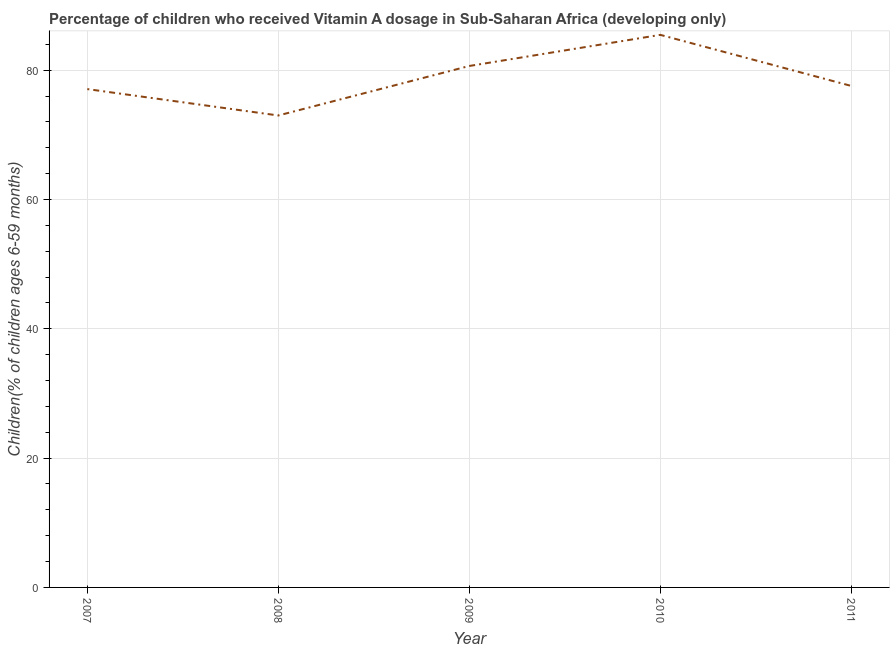What is the vitamin a supplementation coverage rate in 2009?
Make the answer very short. 80.65. Across all years, what is the maximum vitamin a supplementation coverage rate?
Ensure brevity in your answer.  85.46. Across all years, what is the minimum vitamin a supplementation coverage rate?
Make the answer very short. 72.99. In which year was the vitamin a supplementation coverage rate maximum?
Provide a succinct answer. 2010. In which year was the vitamin a supplementation coverage rate minimum?
Ensure brevity in your answer.  2008. What is the sum of the vitamin a supplementation coverage rate?
Offer a very short reply. 393.73. What is the difference between the vitamin a supplementation coverage rate in 2010 and 2011?
Offer a terse response. 7.9. What is the average vitamin a supplementation coverage rate per year?
Ensure brevity in your answer.  78.75. What is the median vitamin a supplementation coverage rate?
Your answer should be very brief. 77.56. Do a majority of the years between 2009 and 2011 (inclusive) have vitamin a supplementation coverage rate greater than 72 %?
Provide a short and direct response. Yes. What is the ratio of the vitamin a supplementation coverage rate in 2008 to that in 2009?
Your answer should be very brief. 0.91. Is the vitamin a supplementation coverage rate in 2010 less than that in 2011?
Your answer should be compact. No. What is the difference between the highest and the second highest vitamin a supplementation coverage rate?
Your response must be concise. 4.81. Is the sum of the vitamin a supplementation coverage rate in 2008 and 2010 greater than the maximum vitamin a supplementation coverage rate across all years?
Ensure brevity in your answer.  Yes. What is the difference between the highest and the lowest vitamin a supplementation coverage rate?
Your response must be concise. 12.47. How many years are there in the graph?
Your answer should be very brief. 5. Does the graph contain any zero values?
Give a very brief answer. No. What is the title of the graph?
Provide a succinct answer. Percentage of children who received Vitamin A dosage in Sub-Saharan Africa (developing only). What is the label or title of the Y-axis?
Your answer should be compact. Children(% of children ages 6-59 months). What is the Children(% of children ages 6-59 months) in 2007?
Give a very brief answer. 77.07. What is the Children(% of children ages 6-59 months) in 2008?
Offer a very short reply. 72.99. What is the Children(% of children ages 6-59 months) of 2009?
Provide a succinct answer. 80.65. What is the Children(% of children ages 6-59 months) of 2010?
Keep it short and to the point. 85.46. What is the Children(% of children ages 6-59 months) in 2011?
Your answer should be very brief. 77.56. What is the difference between the Children(% of children ages 6-59 months) in 2007 and 2008?
Make the answer very short. 4.08. What is the difference between the Children(% of children ages 6-59 months) in 2007 and 2009?
Give a very brief answer. -3.58. What is the difference between the Children(% of children ages 6-59 months) in 2007 and 2010?
Provide a short and direct response. -8.39. What is the difference between the Children(% of children ages 6-59 months) in 2007 and 2011?
Your answer should be compact. -0.49. What is the difference between the Children(% of children ages 6-59 months) in 2008 and 2009?
Make the answer very short. -7.66. What is the difference between the Children(% of children ages 6-59 months) in 2008 and 2010?
Your answer should be compact. -12.47. What is the difference between the Children(% of children ages 6-59 months) in 2008 and 2011?
Provide a short and direct response. -4.57. What is the difference between the Children(% of children ages 6-59 months) in 2009 and 2010?
Your answer should be very brief. -4.81. What is the difference between the Children(% of children ages 6-59 months) in 2009 and 2011?
Offer a very short reply. 3.09. What is the difference between the Children(% of children ages 6-59 months) in 2010 and 2011?
Offer a very short reply. 7.9. What is the ratio of the Children(% of children ages 6-59 months) in 2007 to that in 2008?
Your response must be concise. 1.06. What is the ratio of the Children(% of children ages 6-59 months) in 2007 to that in 2009?
Provide a short and direct response. 0.96. What is the ratio of the Children(% of children ages 6-59 months) in 2007 to that in 2010?
Ensure brevity in your answer.  0.9. What is the ratio of the Children(% of children ages 6-59 months) in 2007 to that in 2011?
Your answer should be compact. 0.99. What is the ratio of the Children(% of children ages 6-59 months) in 2008 to that in 2009?
Ensure brevity in your answer.  0.91. What is the ratio of the Children(% of children ages 6-59 months) in 2008 to that in 2010?
Provide a short and direct response. 0.85. What is the ratio of the Children(% of children ages 6-59 months) in 2008 to that in 2011?
Offer a very short reply. 0.94. What is the ratio of the Children(% of children ages 6-59 months) in 2009 to that in 2010?
Your answer should be very brief. 0.94. What is the ratio of the Children(% of children ages 6-59 months) in 2010 to that in 2011?
Offer a very short reply. 1.1. 